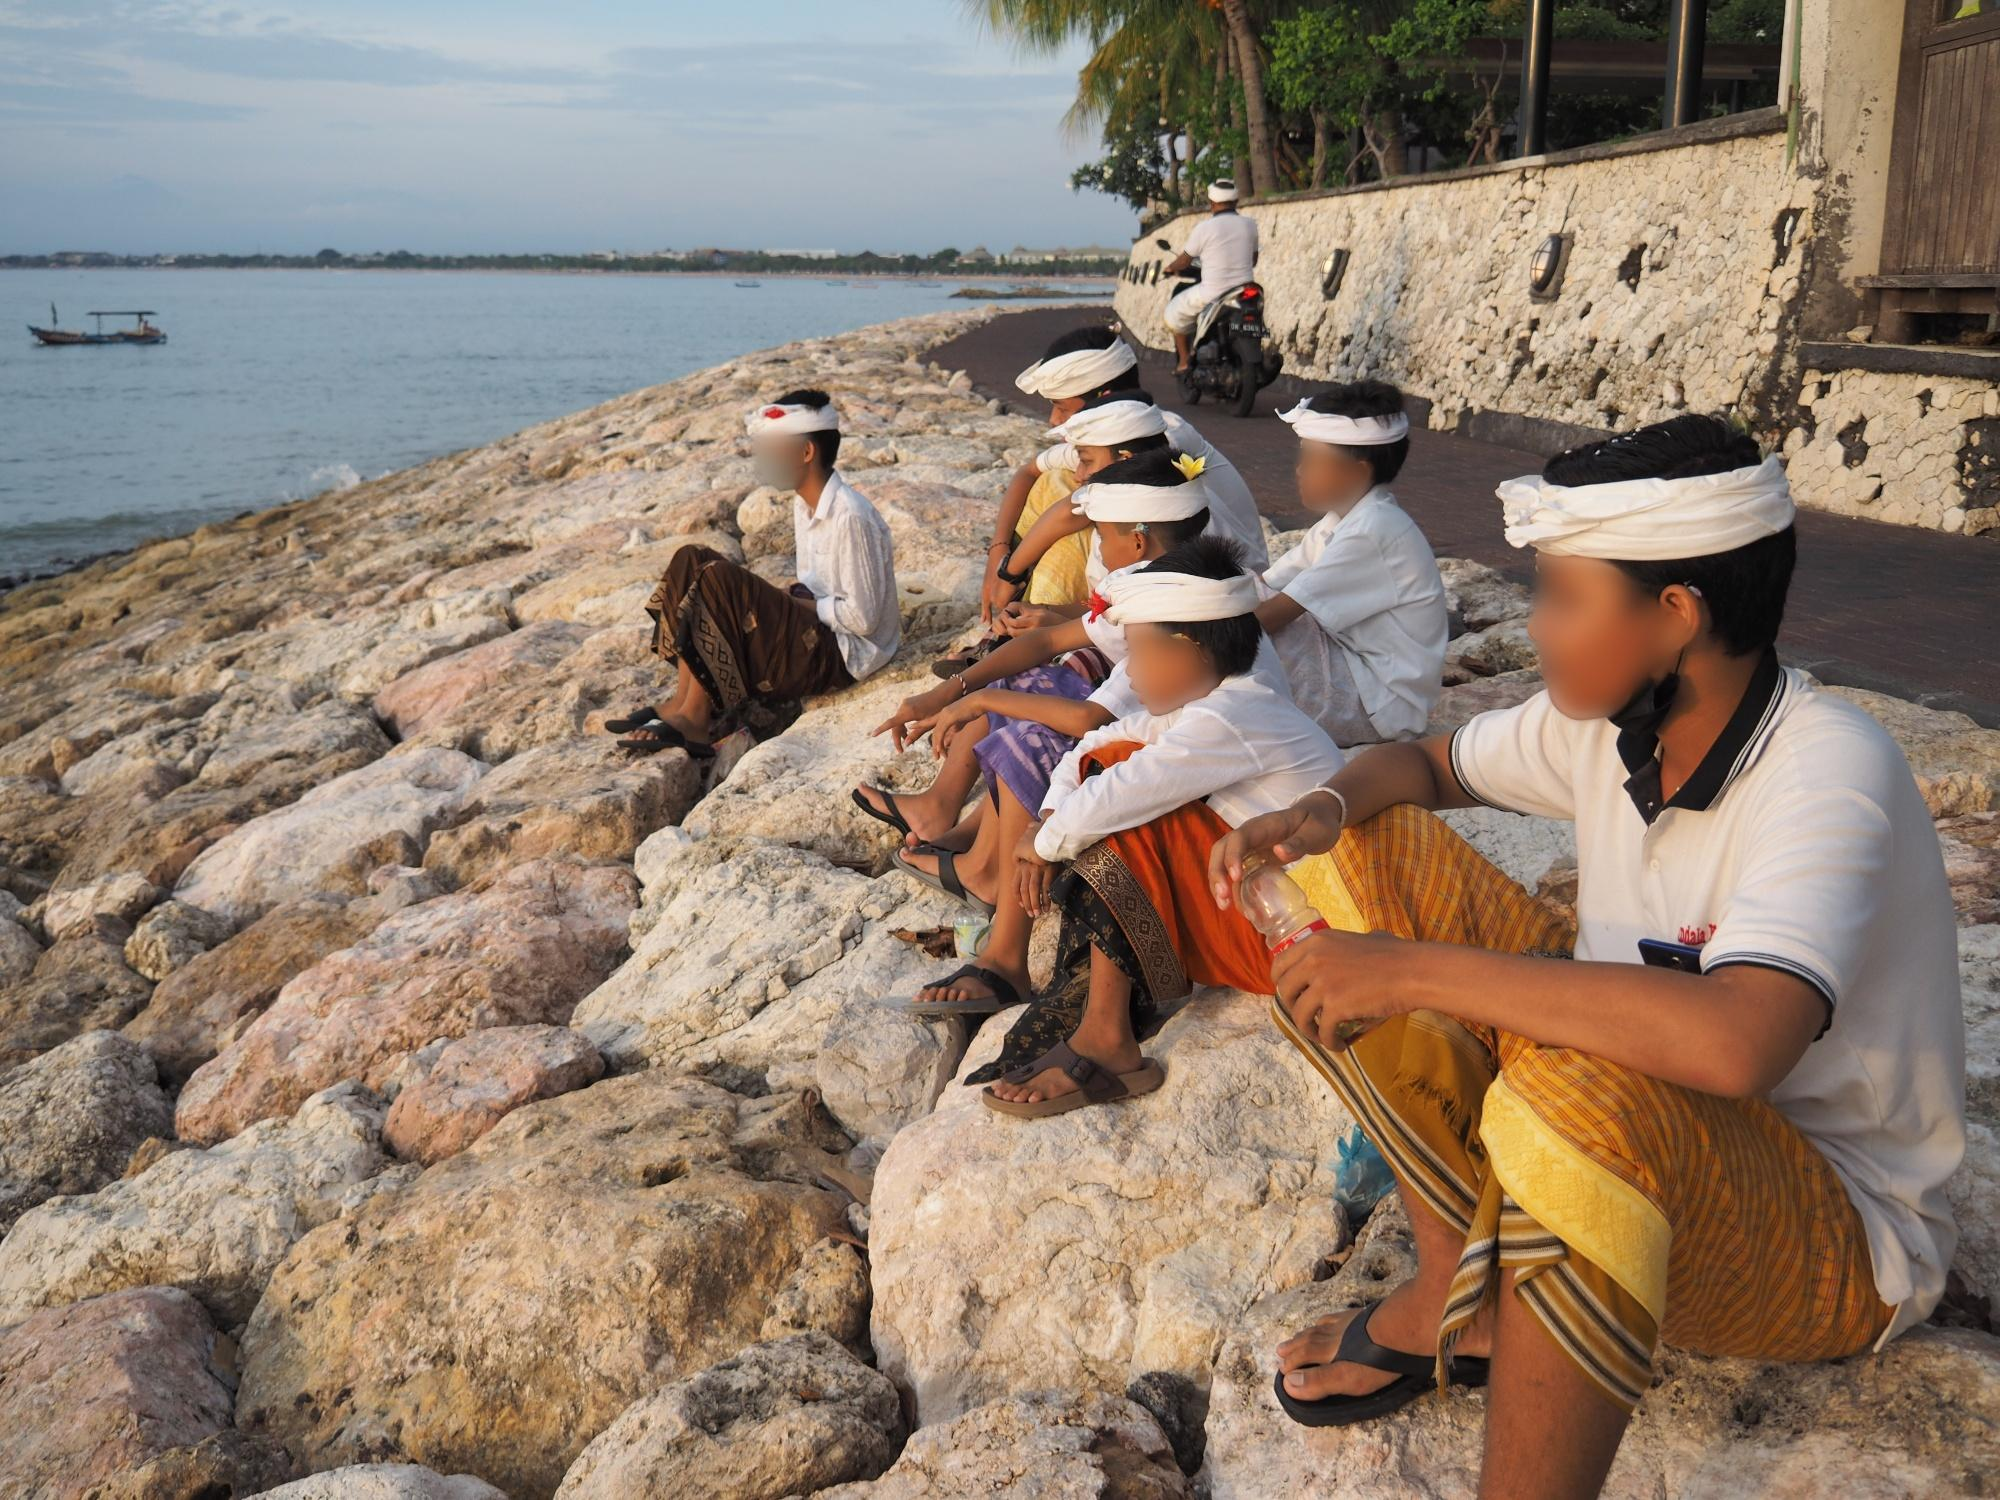Can you describe the cultural elements depicted in this image? The image captures several cultural elements indicative of Balinese tradition. The individuals are dressed in traditional Balinese attire, including sarongs and intricately designed fabrics characterized by vibrant colors and patterns. They also wear traditional headpieces known as 'udeng' for men and 'subas' for women, which are commonly worn during religious ceremonies and cultural festivities in Bali. The setting itself, a rocky shoreline with a vast ocean in the background, aligns with the island's natural landscape, further embedding the scene in its cultural context. What might these individuals be doing here? These individuals could be participating in a traditional Balinese ceremony or ritual, possibly one that involves paying homage to the ocean spirits. Such ceremonies are common in Balinese culture and are often conducted at the water's edge. The relaxed posture of the group suggests a moment of contemplation or rest, perhaps in between ceremonial activities, allowing them to enjoy the natural beauty and tranquility of the coastal setting. Imagine a story behind this scene. In a quiet village on the coast of Bali, a group of friends—Ikhsan, Putu, Ayu, Ganesha, Sari, and Nengah—gather at their favorite spot by the sea to celebrate Galungan, a major Balinese holiday symbolizing the victory of dharma over adharma. Each of them, dressed in their finest traditional clothes and udeng headpieces, has just finished offering a series of prayers and offerings to the ocean deities. The ritual is intended to invite blessings for the community and ensure the continued harmony between the people and the sea. As the sun begins to set, casting golden hues over the rocky shore, they sit and share stories, reminiscing about previous celebrations and the legends of their ancestors. The serene atmosphere and the gentle sound of the waves create a sacred space for their heartfelt connection, reinforcing their spiritual bonds and cultural heritage. 